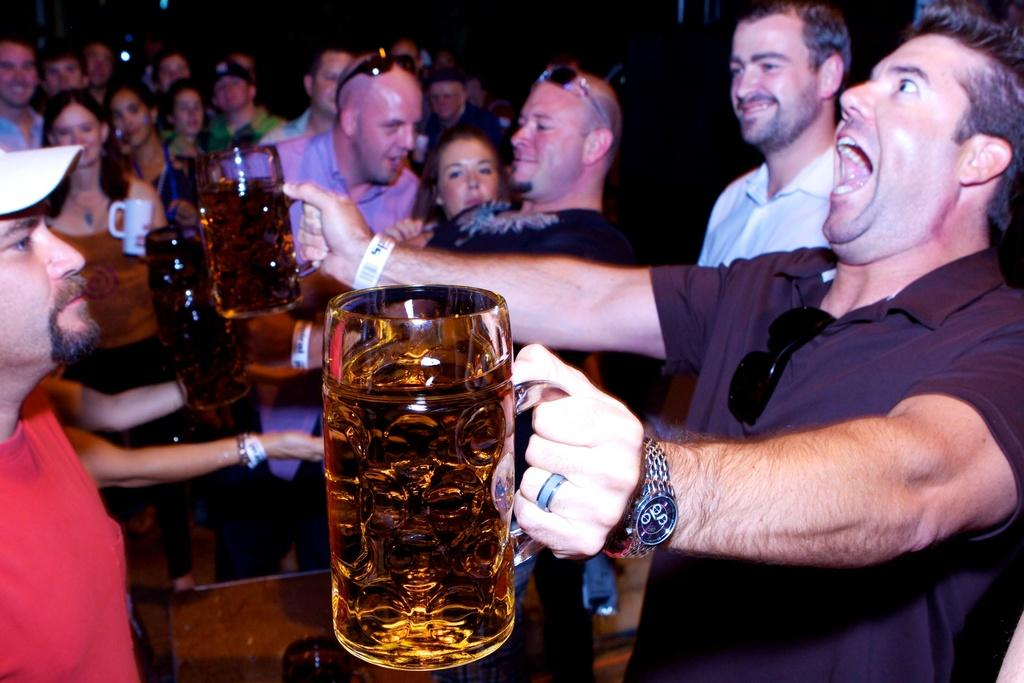How many people are in the image? There are many people in the image. Can you describe the gender distribution of the people in the image? Both men and women are present in the image. What is the man holding in his hands? The man is holding wine glasses in his hands. What type of ear is the grandmother wearing in the image? There is no grandmother or ear present in the image. What is being served for breakfast in the image? There is no mention of breakfast or any food being served in the image. 